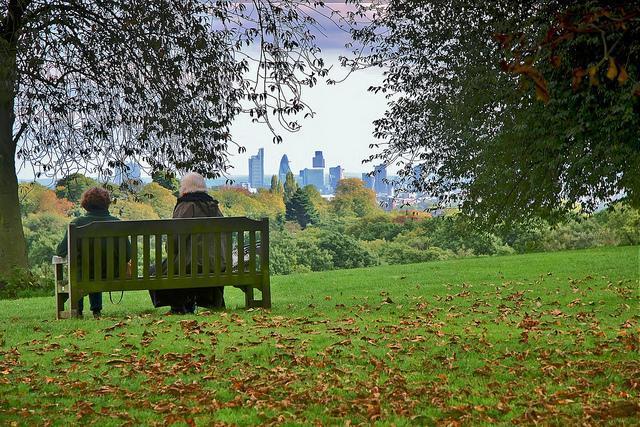How many people are sitting on the bench?
Give a very brief answer. 2. How many people can you see?
Give a very brief answer. 2. 